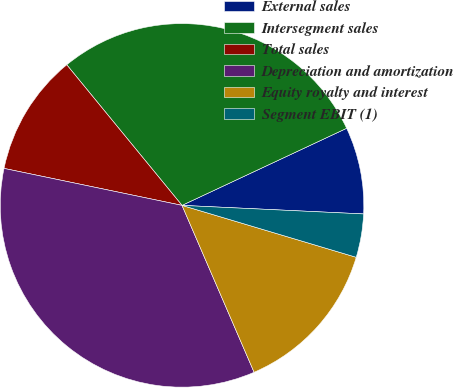Convert chart. <chart><loc_0><loc_0><loc_500><loc_500><pie_chart><fcel>External sales<fcel>Intersegment sales<fcel>Total sales<fcel>Depreciation and amortization<fcel>Equity royalty and interest<fcel>Segment EBIT (1)<nl><fcel>7.72%<fcel>28.96%<fcel>10.81%<fcel>34.75%<fcel>13.9%<fcel>3.86%<nl></chart> 